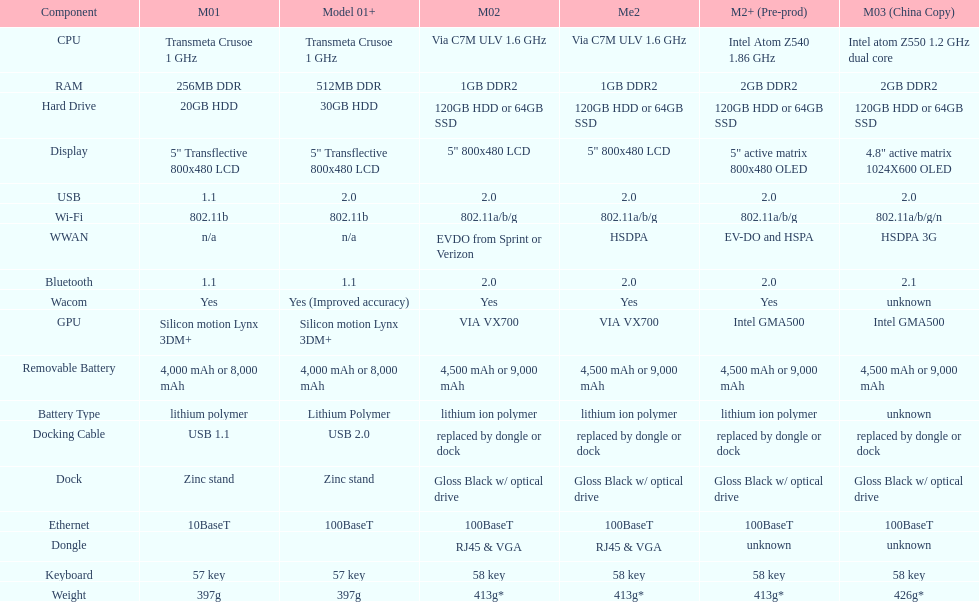How much heavier is model 3 compared to model 1? 29g. Give me the full table as a dictionary. {'header': ['Component', 'M01', 'Model 01+', 'M02', 'Me2', 'M2+ (Pre-prod)', 'M03 (China Copy)'], 'rows': [['CPU', 'Transmeta Crusoe 1\xa0GHz', 'Transmeta Crusoe 1\xa0GHz', 'Via C7M ULV 1.6\xa0GHz', 'Via C7M ULV 1.6\xa0GHz', 'Intel Atom Z540 1.86\xa0GHz', 'Intel atom Z550 1.2\xa0GHz dual core'], ['RAM', '256MB DDR', '512MB DDR', '1GB DDR2', '1GB DDR2', '2GB DDR2', '2GB DDR2'], ['Hard Drive', '20GB HDD', '30GB HDD', '120GB HDD or 64GB SSD', '120GB HDD or 64GB SSD', '120GB HDD or 64GB SSD', '120GB HDD or 64GB SSD'], ['Display', '5" Transflective 800x480 LCD', '5" Transflective 800x480 LCD', '5" 800x480 LCD', '5" 800x480 LCD', '5" active matrix 800x480 OLED', '4.8" active matrix 1024X600 OLED'], ['USB', '1.1', '2.0', '2.0', '2.0', '2.0', '2.0'], ['Wi-Fi', '802.11b', '802.11b', '802.11a/b/g', '802.11a/b/g', '802.11a/b/g', '802.11a/b/g/n'], ['WWAN', 'n/a', 'n/a', 'EVDO from Sprint or Verizon', 'HSDPA', 'EV-DO and HSPA', 'HSDPA 3G'], ['Bluetooth', '1.1', '1.1', '2.0', '2.0', '2.0', '2.1'], ['Wacom', 'Yes', 'Yes (Improved accuracy)', 'Yes', 'Yes', 'Yes', 'unknown'], ['GPU', 'Silicon motion Lynx 3DM+', 'Silicon motion Lynx 3DM+', 'VIA VX700', 'VIA VX700', 'Intel GMA500', 'Intel GMA500'], ['Removable Battery', '4,000 mAh or 8,000 mAh', '4,000 mAh or 8,000 mAh', '4,500 mAh or 9,000 mAh', '4,500 mAh or 9,000 mAh', '4,500 mAh or 9,000 mAh', '4,500 mAh or 9,000 mAh'], ['Battery Type', 'lithium polymer', 'Lithium Polymer', 'lithium ion polymer', 'lithium ion polymer', 'lithium ion polymer', 'unknown'], ['Docking Cable', 'USB 1.1', 'USB 2.0', 'replaced by dongle or dock', 'replaced by dongle or dock', 'replaced by dongle or dock', 'replaced by dongle or dock'], ['Dock', 'Zinc stand', 'Zinc stand', 'Gloss Black w/ optical drive', 'Gloss Black w/ optical drive', 'Gloss Black w/ optical drive', 'Gloss Black w/ optical drive'], ['Ethernet', '10BaseT', '100BaseT', '100BaseT', '100BaseT', '100BaseT', '100BaseT'], ['Dongle', '', '', 'RJ45 & VGA', 'RJ45 & VGA', 'unknown', 'unknown'], ['Keyboard', '57 key', '57 key', '58 key', '58 key', '58 key', '58 key'], ['Weight', '397g', '397g', '413g*', '413g*', '413g*', '426g*']]} 